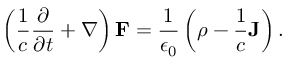<formula> <loc_0><loc_0><loc_500><loc_500>\left ( { \frac { 1 } { c } } { \frac { \partial } { \partial t } } + { \nabla } \right ) F = { \frac { 1 } { \epsilon _ { 0 } } } \left ( \rho - { \frac { 1 } { c } } J \right ) .</formula> 